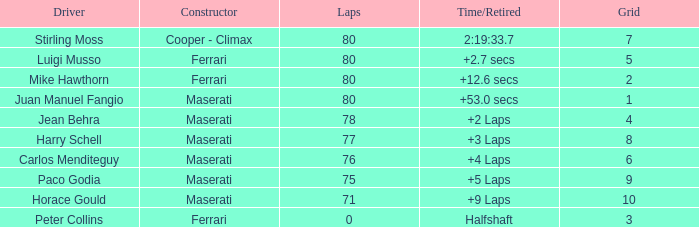I'm looking to parse the entire table for insights. Could you assist me with that? {'header': ['Driver', 'Constructor', 'Laps', 'Time/Retired', 'Grid'], 'rows': [['Stirling Moss', 'Cooper - Climax', '80', '2:19:33.7', '7'], ['Luigi Musso', 'Ferrari', '80', '+2.7 secs', '5'], ['Mike Hawthorn', 'Ferrari', '80', '+12.6 secs', '2'], ['Juan Manuel Fangio', 'Maserati', '80', '+53.0 secs', '1'], ['Jean Behra', 'Maserati', '78', '+2 Laps', '4'], ['Harry Schell', 'Maserati', '77', '+3 Laps', '8'], ['Carlos Menditeguy', 'Maserati', '76', '+4 Laps', '6'], ['Paco Godia', 'Maserati', '75', '+5 Laps', '9'], ['Horace Gould', 'Maserati', '71', '+9 Laps', '10'], ['Peter Collins', 'Ferrari', '0', 'Halfshaft', '3']]} Who was driving the Maserati with a Grid smaller than 6, and a Time/Retired of +2 laps? Jean Behra. 